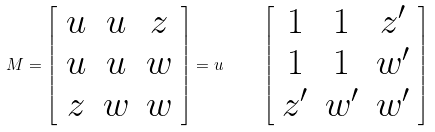<formula> <loc_0><loc_0><loc_500><loc_500>M = \left [ \begin{array} { c c c } u & u & z \\ u & u & w \\ z & w & w \end{array} \right ] = u \quad \left [ \begin{array} { c c c } 1 & 1 & z ^ { \prime } \\ 1 & 1 & w ^ { \prime } \\ z ^ { \prime } & w ^ { \prime } & w ^ { \prime } \end{array} \right ]</formula> 